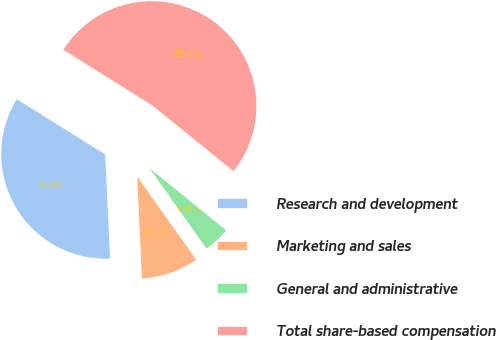Convert chart. <chart><loc_0><loc_0><loc_500><loc_500><pie_chart><fcel>Research and development<fcel>Marketing and sales<fcel>General and administrative<fcel>Total share-based compensation<nl><fcel>34.63%<fcel>9.09%<fcel>4.33%<fcel>51.95%<nl></chart> 